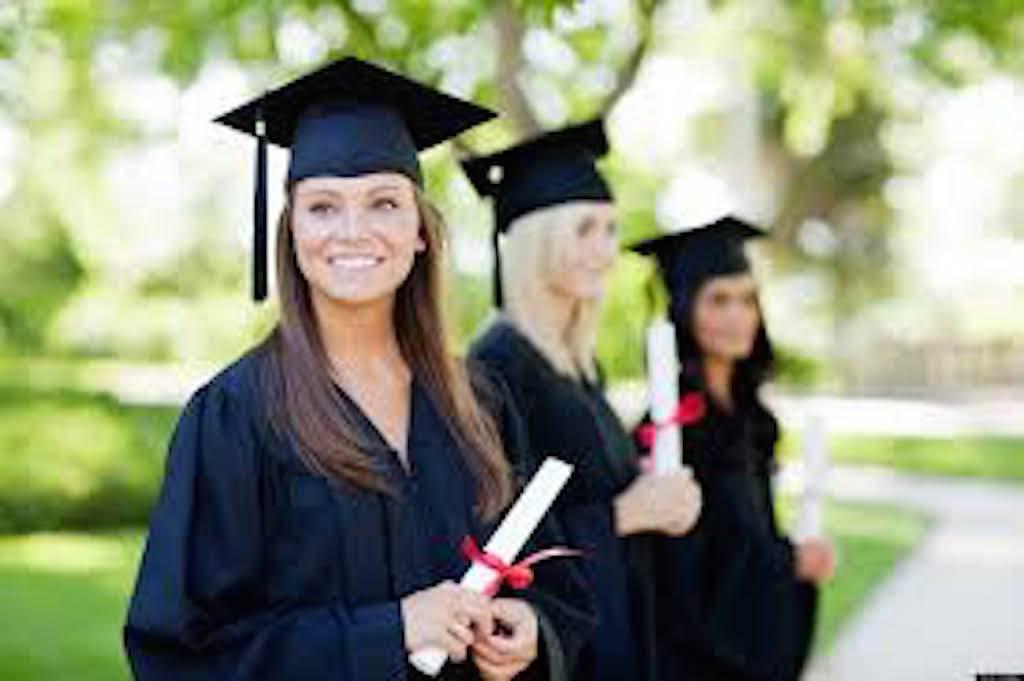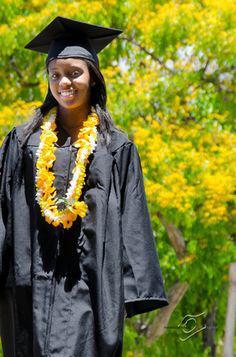The first image is the image on the left, the second image is the image on the right. For the images displayed, is the sentence "The left image contains exactly two people wearing graduation uniforms." factually correct? Answer yes or no. No. The first image is the image on the left, the second image is the image on the right. Given the left and right images, does the statement "One picture has atleast 2 women in it." hold true? Answer yes or no. Yes. 